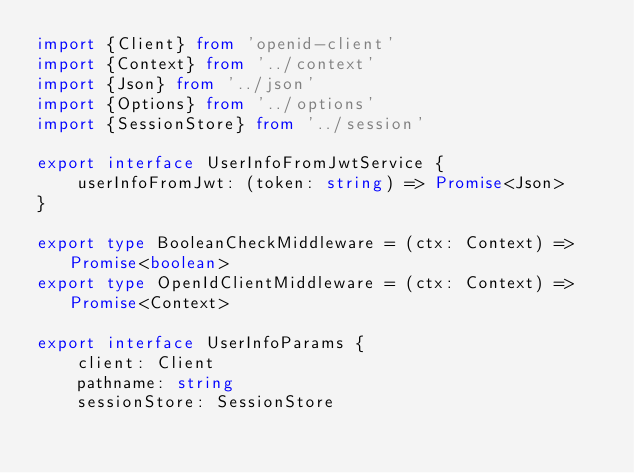Convert code to text. <code><loc_0><loc_0><loc_500><loc_500><_TypeScript_>import {Client} from 'openid-client'
import {Context} from '../context'
import {Json} from '../json'
import {Options} from '../options'
import {SessionStore} from '../session'

export interface UserInfoFromJwtService {
    userInfoFromJwt: (token: string) => Promise<Json>
}

export type BooleanCheckMiddleware = (ctx: Context) => Promise<boolean>
export type OpenIdClientMiddleware = (ctx: Context) => Promise<Context>

export interface UserInfoParams {
    client: Client
    pathname: string
    sessionStore: SessionStore</code> 